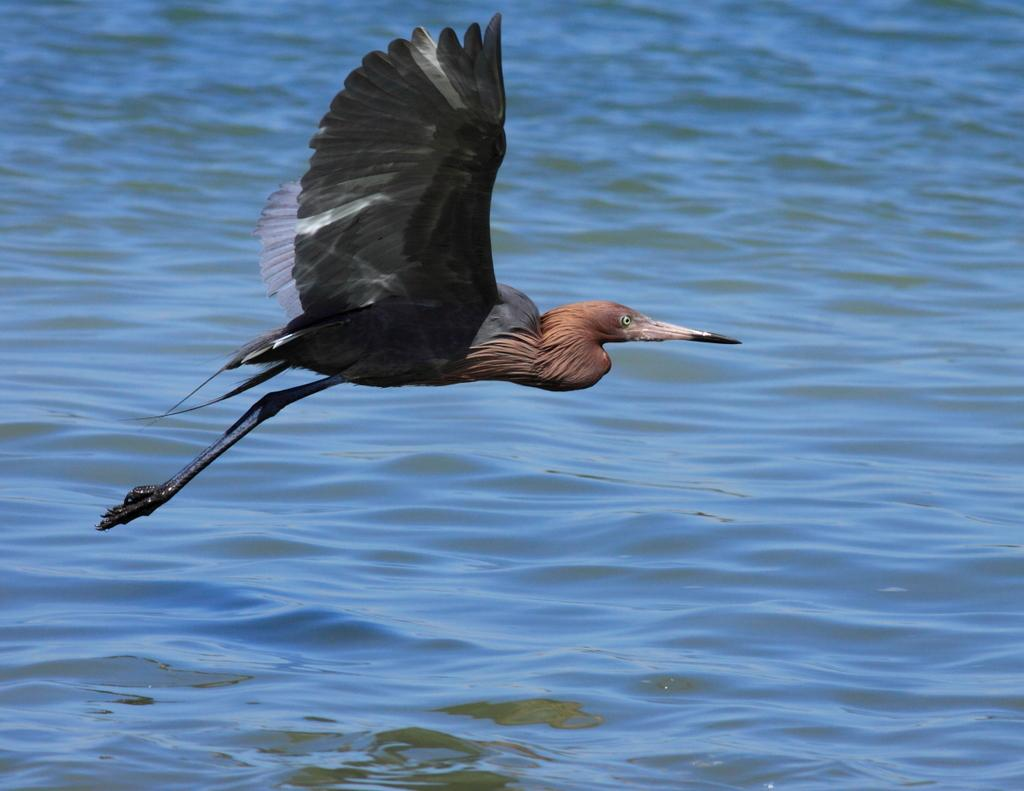What is happening in the middle of the image? There is a bird flying in the air in the middle of the image. What can be seen in the background of the image? There is water visible in the background of the image. What type of lace is being used to decorate the bird's wings in the image? There is no lace present in the image, and the bird's wings are not being decorated. 